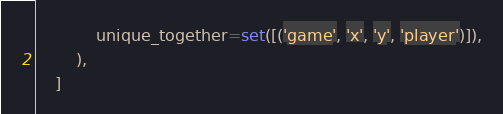Convert code to text. <code><loc_0><loc_0><loc_500><loc_500><_Python_>            unique_together=set([('game', 'x', 'y', 'player')]),
        ),
    ]
</code> 